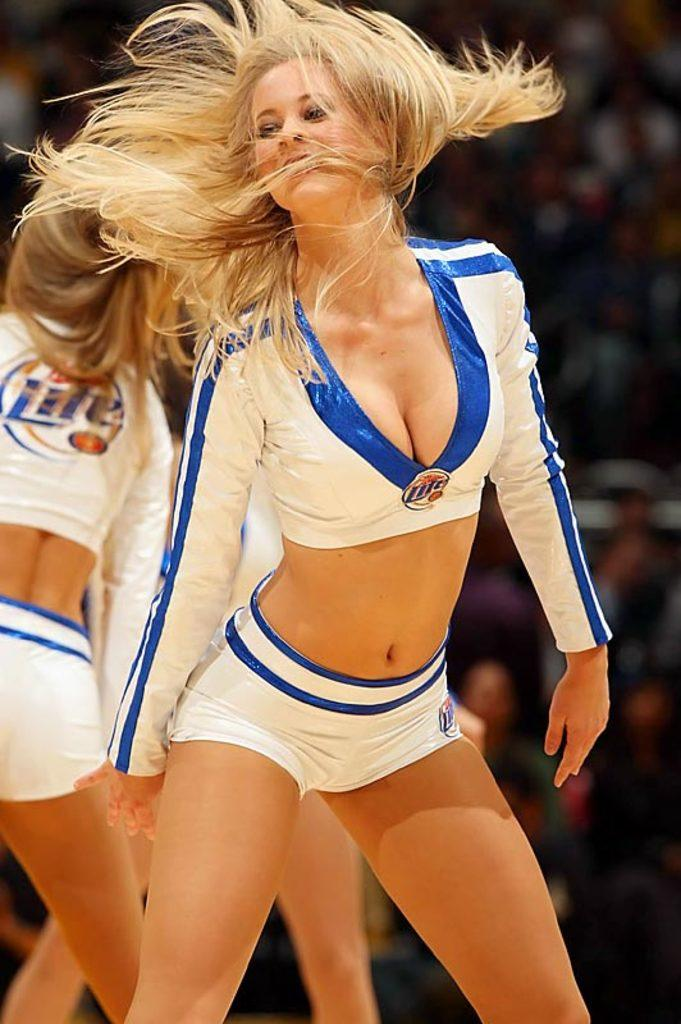<image>
Render a clear and concise summary of the photo. A cheerleader in a blue and white outfit with the word Lite on it 